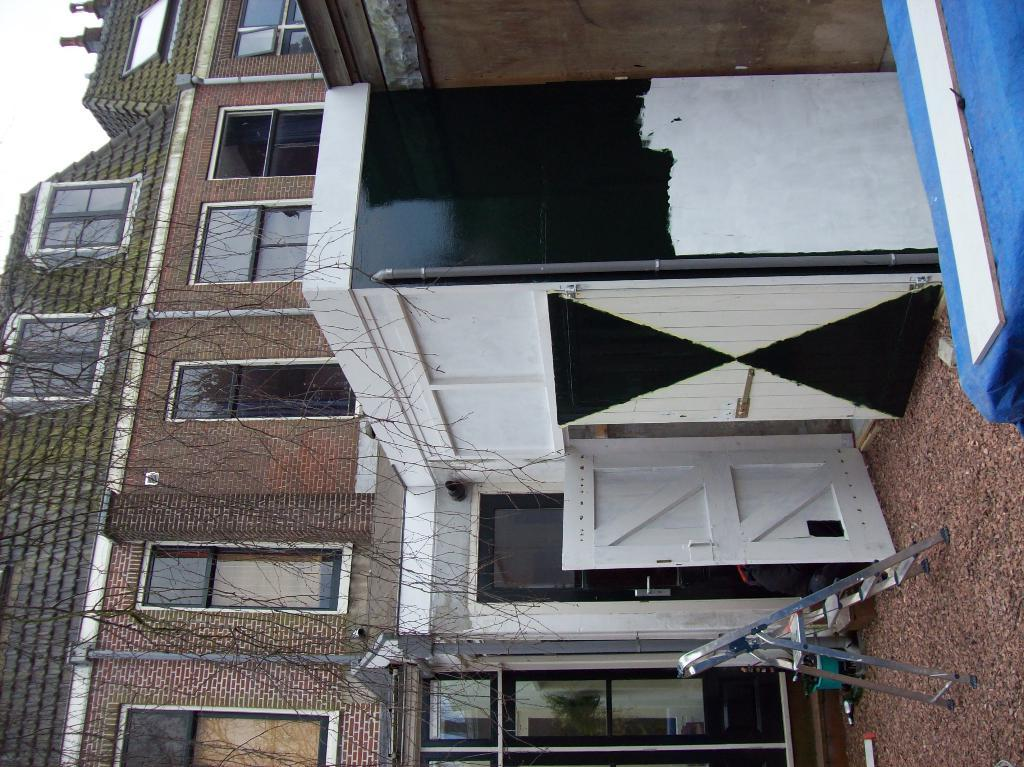What type of door is visible in the image? There is a white door in the image. What can be seen in the background of the image? There is a building in the background of the image. What is the color of the building? The building is brown in color. Are there any openings in the building visible in the image? Yes, there are windows visible in the image. What is the color of the sky in the image? The sky is white in color. What type of paper is being used to write on the cart in the image? There is no cart or paper present in the image. 